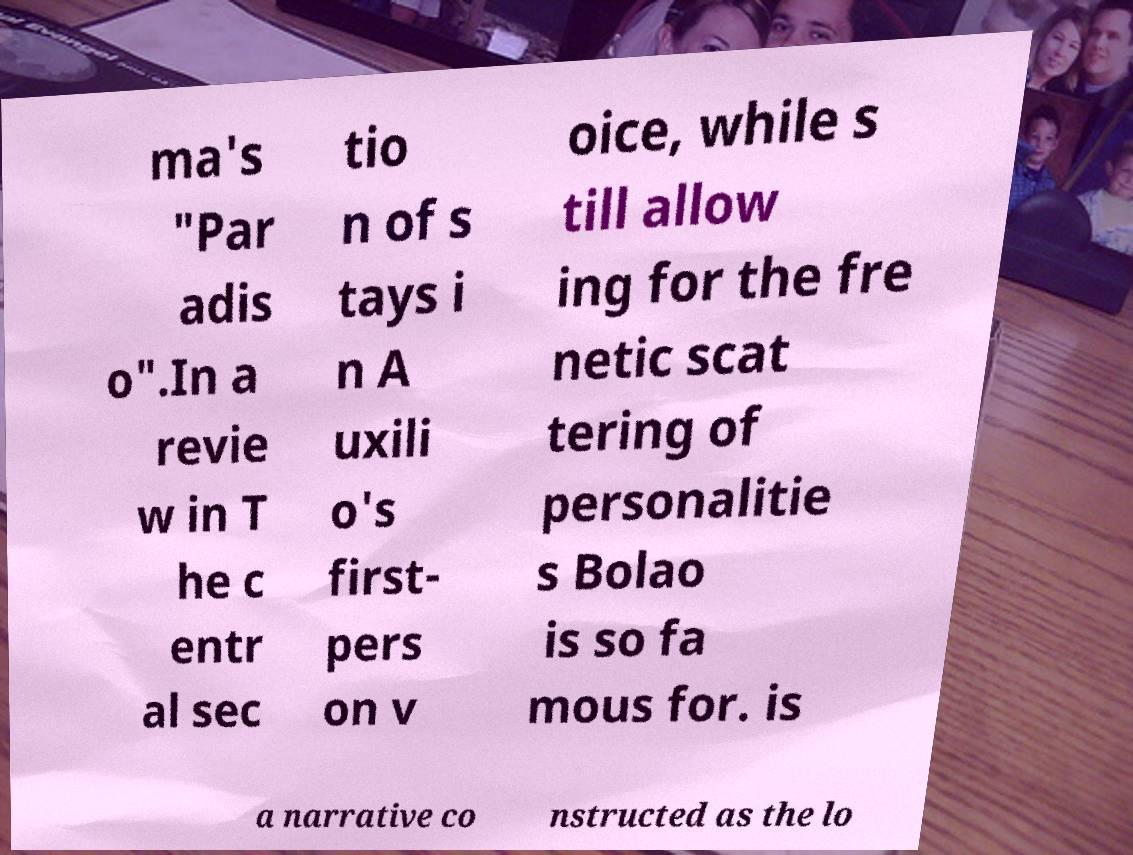What messages or text are displayed in this image? I need them in a readable, typed format. ma's "Par adis o".In a revie w in T he c entr al sec tio n of s tays i n A uxili o's first- pers on v oice, while s till allow ing for the fre netic scat tering of personalitie s Bolao is so fa mous for. is a narrative co nstructed as the lo 